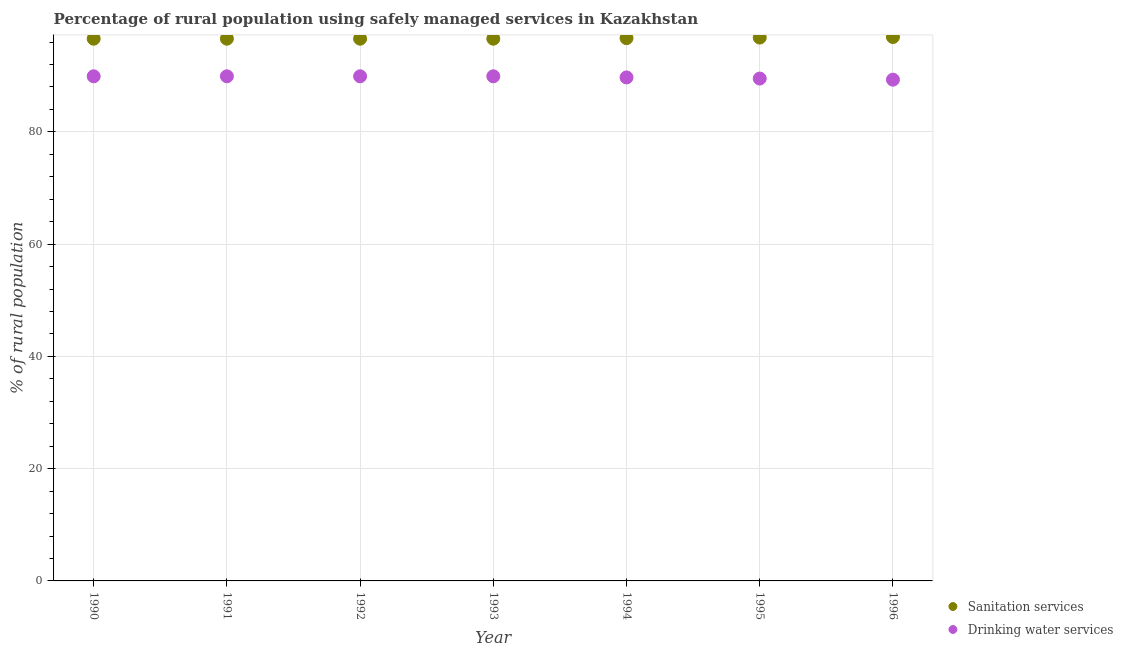How many different coloured dotlines are there?
Your answer should be compact. 2. What is the percentage of rural population who used drinking water services in 1995?
Make the answer very short. 89.5. Across all years, what is the maximum percentage of rural population who used drinking water services?
Provide a succinct answer. 89.9. Across all years, what is the minimum percentage of rural population who used sanitation services?
Keep it short and to the point. 96.6. In which year was the percentage of rural population who used sanitation services minimum?
Your answer should be compact. 1990. What is the total percentage of rural population who used drinking water services in the graph?
Give a very brief answer. 628.1. What is the difference between the percentage of rural population who used sanitation services in 1992 and that in 1993?
Make the answer very short. 0. What is the difference between the percentage of rural population who used sanitation services in 1994 and the percentage of rural population who used drinking water services in 1995?
Give a very brief answer. 7.2. What is the average percentage of rural population who used drinking water services per year?
Offer a very short reply. 89.73. In the year 1993, what is the difference between the percentage of rural population who used drinking water services and percentage of rural population who used sanitation services?
Your answer should be very brief. -6.7. What is the ratio of the percentage of rural population who used drinking water services in 1990 to that in 1994?
Your response must be concise. 1. What is the difference between the highest and the lowest percentage of rural population who used sanitation services?
Give a very brief answer. 0.3. In how many years, is the percentage of rural population who used drinking water services greater than the average percentage of rural population who used drinking water services taken over all years?
Your answer should be compact. 4. Is the sum of the percentage of rural population who used sanitation services in 1990 and 1995 greater than the maximum percentage of rural population who used drinking water services across all years?
Offer a terse response. Yes. Is the percentage of rural population who used sanitation services strictly greater than the percentage of rural population who used drinking water services over the years?
Your response must be concise. Yes. Is the percentage of rural population who used sanitation services strictly less than the percentage of rural population who used drinking water services over the years?
Offer a terse response. No. How many years are there in the graph?
Give a very brief answer. 7. Does the graph contain grids?
Offer a terse response. Yes. How many legend labels are there?
Keep it short and to the point. 2. What is the title of the graph?
Make the answer very short. Percentage of rural population using safely managed services in Kazakhstan. What is the label or title of the X-axis?
Make the answer very short. Year. What is the label or title of the Y-axis?
Ensure brevity in your answer.  % of rural population. What is the % of rural population in Sanitation services in 1990?
Offer a terse response. 96.6. What is the % of rural population of Drinking water services in 1990?
Give a very brief answer. 89.9. What is the % of rural population of Sanitation services in 1991?
Your answer should be very brief. 96.6. What is the % of rural population in Drinking water services in 1991?
Ensure brevity in your answer.  89.9. What is the % of rural population in Sanitation services in 1992?
Ensure brevity in your answer.  96.6. What is the % of rural population in Drinking water services in 1992?
Give a very brief answer. 89.9. What is the % of rural population of Sanitation services in 1993?
Make the answer very short. 96.6. What is the % of rural population of Drinking water services in 1993?
Your answer should be compact. 89.9. What is the % of rural population of Sanitation services in 1994?
Ensure brevity in your answer.  96.7. What is the % of rural population of Drinking water services in 1994?
Make the answer very short. 89.7. What is the % of rural population of Sanitation services in 1995?
Provide a short and direct response. 96.8. What is the % of rural population in Drinking water services in 1995?
Provide a succinct answer. 89.5. What is the % of rural population in Sanitation services in 1996?
Your response must be concise. 96.9. What is the % of rural population of Drinking water services in 1996?
Provide a succinct answer. 89.3. Across all years, what is the maximum % of rural population in Sanitation services?
Provide a succinct answer. 96.9. Across all years, what is the maximum % of rural population of Drinking water services?
Offer a very short reply. 89.9. Across all years, what is the minimum % of rural population in Sanitation services?
Ensure brevity in your answer.  96.6. Across all years, what is the minimum % of rural population of Drinking water services?
Offer a very short reply. 89.3. What is the total % of rural population of Sanitation services in the graph?
Your answer should be compact. 676.8. What is the total % of rural population in Drinking water services in the graph?
Your answer should be compact. 628.1. What is the difference between the % of rural population of Sanitation services in 1990 and that in 1991?
Give a very brief answer. 0. What is the difference between the % of rural population of Drinking water services in 1990 and that in 1991?
Provide a succinct answer. 0. What is the difference between the % of rural population in Sanitation services in 1990 and that in 1992?
Ensure brevity in your answer.  0. What is the difference between the % of rural population in Sanitation services in 1990 and that in 1993?
Offer a terse response. 0. What is the difference between the % of rural population in Drinking water services in 1990 and that in 1993?
Make the answer very short. 0. What is the difference between the % of rural population in Sanitation services in 1990 and that in 1994?
Provide a short and direct response. -0.1. What is the difference between the % of rural population of Drinking water services in 1990 and that in 1994?
Offer a very short reply. 0.2. What is the difference between the % of rural population of Drinking water services in 1990 and that in 1996?
Offer a very short reply. 0.6. What is the difference between the % of rural population in Sanitation services in 1991 and that in 1993?
Ensure brevity in your answer.  0. What is the difference between the % of rural population of Sanitation services in 1991 and that in 1994?
Offer a terse response. -0.1. What is the difference between the % of rural population in Drinking water services in 1991 and that in 1994?
Provide a succinct answer. 0.2. What is the difference between the % of rural population of Sanitation services in 1991 and that in 1995?
Your answer should be very brief. -0.2. What is the difference between the % of rural population in Drinking water services in 1991 and that in 1995?
Ensure brevity in your answer.  0.4. What is the difference between the % of rural population of Drinking water services in 1991 and that in 1996?
Provide a succinct answer. 0.6. What is the difference between the % of rural population in Drinking water services in 1992 and that in 1993?
Your answer should be very brief. 0. What is the difference between the % of rural population of Drinking water services in 1992 and that in 1994?
Keep it short and to the point. 0.2. What is the difference between the % of rural population in Sanitation services in 1992 and that in 1995?
Keep it short and to the point. -0.2. What is the difference between the % of rural population of Drinking water services in 1992 and that in 1995?
Keep it short and to the point. 0.4. What is the difference between the % of rural population in Sanitation services in 1992 and that in 1996?
Your answer should be compact. -0.3. What is the difference between the % of rural population of Drinking water services in 1992 and that in 1996?
Your answer should be compact. 0.6. What is the difference between the % of rural population in Sanitation services in 1993 and that in 1994?
Ensure brevity in your answer.  -0.1. What is the difference between the % of rural population of Drinking water services in 1993 and that in 1995?
Your response must be concise. 0.4. What is the difference between the % of rural population in Drinking water services in 1993 and that in 1996?
Ensure brevity in your answer.  0.6. What is the difference between the % of rural population of Drinking water services in 1994 and that in 1996?
Offer a terse response. 0.4. What is the difference between the % of rural population of Sanitation services in 1995 and that in 1996?
Provide a short and direct response. -0.1. What is the difference between the % of rural population in Sanitation services in 1990 and the % of rural population in Drinking water services in 1994?
Keep it short and to the point. 6.9. What is the difference between the % of rural population of Sanitation services in 1990 and the % of rural population of Drinking water services in 1995?
Ensure brevity in your answer.  7.1. What is the difference between the % of rural population of Sanitation services in 1990 and the % of rural population of Drinking water services in 1996?
Ensure brevity in your answer.  7.3. What is the difference between the % of rural population of Sanitation services in 1991 and the % of rural population of Drinking water services in 1993?
Give a very brief answer. 6.7. What is the difference between the % of rural population in Sanitation services in 1991 and the % of rural population in Drinking water services in 1994?
Keep it short and to the point. 6.9. What is the difference between the % of rural population of Sanitation services in 1992 and the % of rural population of Drinking water services in 1995?
Make the answer very short. 7.1. What is the difference between the % of rural population of Sanitation services in 1992 and the % of rural population of Drinking water services in 1996?
Keep it short and to the point. 7.3. What is the difference between the % of rural population in Sanitation services in 1993 and the % of rural population in Drinking water services in 1994?
Keep it short and to the point. 6.9. What is the difference between the % of rural population of Sanitation services in 1993 and the % of rural population of Drinking water services in 1995?
Provide a short and direct response. 7.1. What is the average % of rural population of Sanitation services per year?
Keep it short and to the point. 96.69. What is the average % of rural population of Drinking water services per year?
Provide a short and direct response. 89.73. In the year 1992, what is the difference between the % of rural population in Sanitation services and % of rural population in Drinking water services?
Provide a short and direct response. 6.7. In the year 1993, what is the difference between the % of rural population in Sanitation services and % of rural population in Drinking water services?
Offer a terse response. 6.7. In the year 1996, what is the difference between the % of rural population in Sanitation services and % of rural population in Drinking water services?
Your response must be concise. 7.6. What is the ratio of the % of rural population of Sanitation services in 1990 to that in 1991?
Your answer should be very brief. 1. What is the ratio of the % of rural population of Sanitation services in 1990 to that in 1992?
Provide a short and direct response. 1. What is the ratio of the % of rural population of Drinking water services in 1990 to that in 1992?
Give a very brief answer. 1. What is the ratio of the % of rural population in Sanitation services in 1990 to that in 1994?
Your answer should be compact. 1. What is the ratio of the % of rural population of Drinking water services in 1990 to that in 1994?
Keep it short and to the point. 1. What is the ratio of the % of rural population in Drinking water services in 1990 to that in 1995?
Make the answer very short. 1. What is the ratio of the % of rural population in Sanitation services in 1990 to that in 1996?
Make the answer very short. 1. What is the ratio of the % of rural population in Drinking water services in 1990 to that in 1996?
Ensure brevity in your answer.  1.01. What is the ratio of the % of rural population in Drinking water services in 1991 to that in 1993?
Your answer should be compact. 1. What is the ratio of the % of rural population of Sanitation services in 1991 to that in 1994?
Your answer should be compact. 1. What is the ratio of the % of rural population in Drinking water services in 1991 to that in 1995?
Provide a succinct answer. 1. What is the ratio of the % of rural population of Drinking water services in 1991 to that in 1996?
Ensure brevity in your answer.  1.01. What is the ratio of the % of rural population in Sanitation services in 1992 to that in 1993?
Give a very brief answer. 1. What is the ratio of the % of rural population in Drinking water services in 1992 to that in 1993?
Ensure brevity in your answer.  1. What is the ratio of the % of rural population of Sanitation services in 1992 to that in 1994?
Provide a succinct answer. 1. What is the ratio of the % of rural population in Drinking water services in 1992 to that in 1994?
Your answer should be very brief. 1. What is the ratio of the % of rural population of Drinking water services in 1992 to that in 1995?
Make the answer very short. 1. What is the ratio of the % of rural population of Drinking water services in 1993 to that in 1994?
Offer a very short reply. 1. What is the ratio of the % of rural population of Sanitation services in 1993 to that in 1995?
Ensure brevity in your answer.  1. What is the ratio of the % of rural population in Drinking water services in 1993 to that in 1995?
Your answer should be compact. 1. What is the ratio of the % of rural population of Drinking water services in 1993 to that in 1996?
Make the answer very short. 1.01. What is the ratio of the % of rural population in Sanitation services in 1994 to that in 1996?
Provide a short and direct response. 1. What is the ratio of the % of rural population of Sanitation services in 1995 to that in 1996?
Your response must be concise. 1. What is the difference between the highest and the second highest % of rural population in Sanitation services?
Keep it short and to the point. 0.1. What is the difference between the highest and the second highest % of rural population of Drinking water services?
Offer a very short reply. 0. What is the difference between the highest and the lowest % of rural population of Drinking water services?
Give a very brief answer. 0.6. 